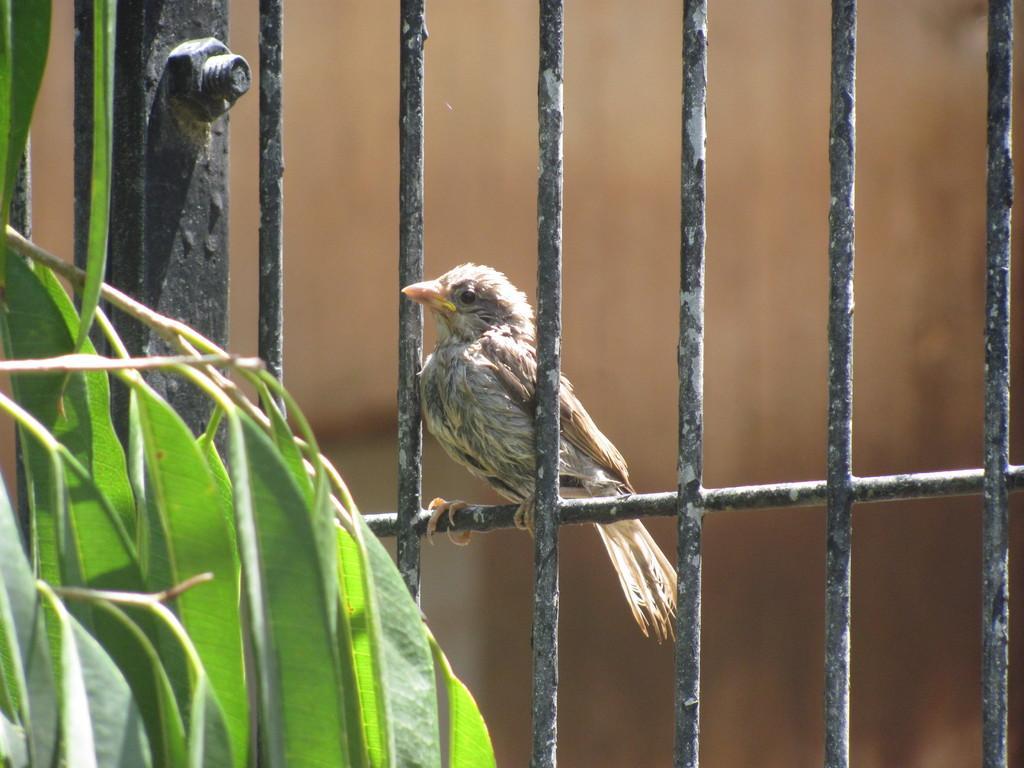Please provide a concise description of this image. In this image there is a railing, on that railing there is a bird, on the left side there are leaves, in the background it is blurred. 